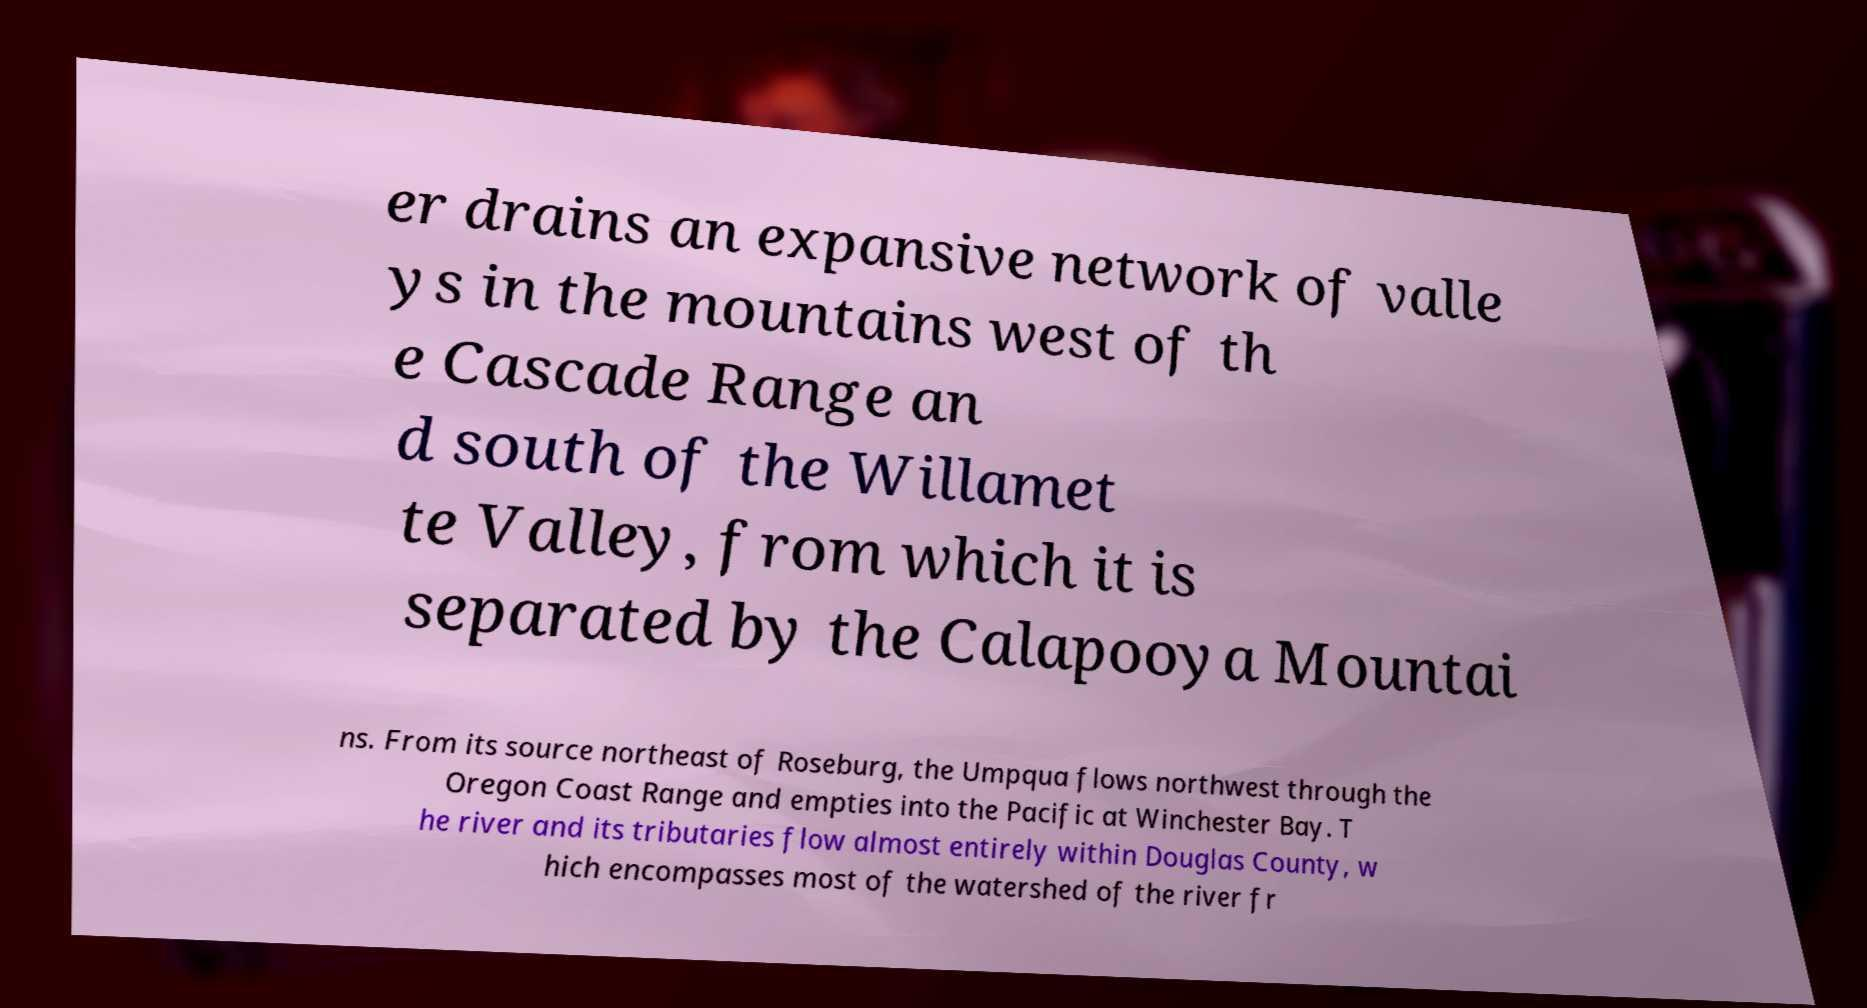There's text embedded in this image that I need extracted. Can you transcribe it verbatim? er drains an expansive network of valle ys in the mountains west of th e Cascade Range an d south of the Willamet te Valley, from which it is separated by the Calapooya Mountai ns. From its source northeast of Roseburg, the Umpqua flows northwest through the Oregon Coast Range and empties into the Pacific at Winchester Bay. T he river and its tributaries flow almost entirely within Douglas County, w hich encompasses most of the watershed of the river fr 